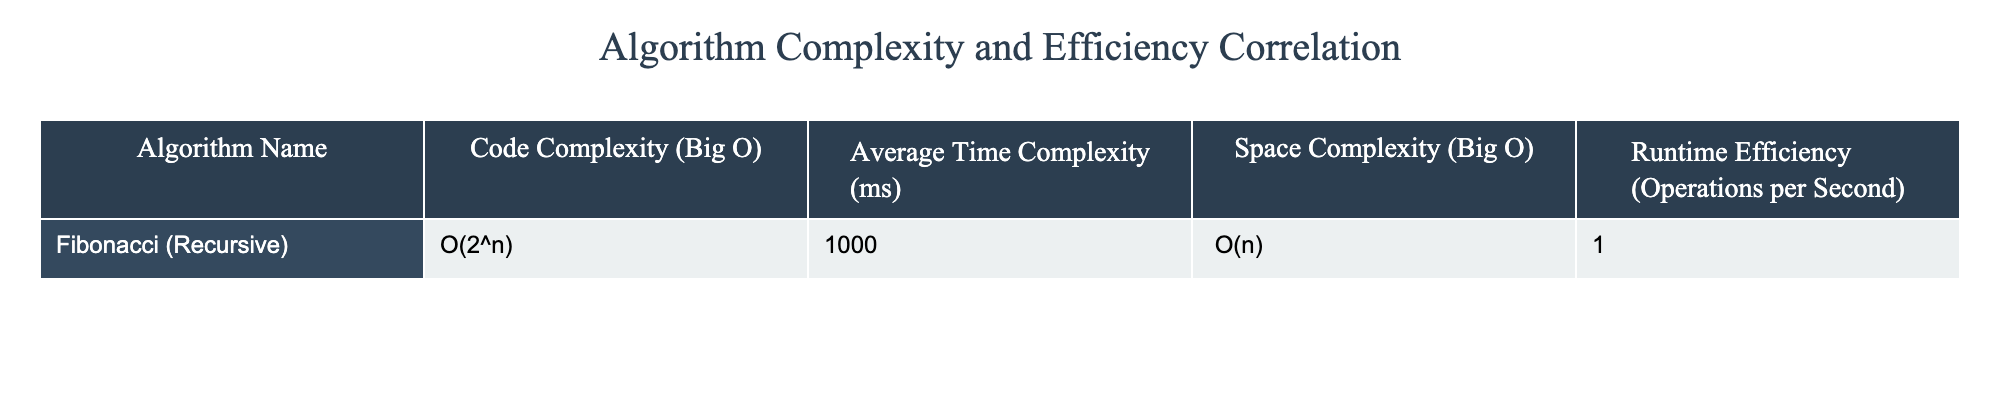What is the code complexity of the Fibonacci algorithm? The table lists the code complexity for the Fibonacci algorithm as O(2^n). This value can be found directly in the "Code Complexity (Big O)" column next to the Fibonacci algorithm name.
Answer: O(2^n) How much average time does the Fibonacci algorithm take to execute? The table provides the average time complexity in milliseconds for the Fibonacci algorithm, which is 1000 ms, easily referenced in the "Average Time Complexity (ms)" column.
Answer: 1000 ms What is the space complexity of the Fibonacci algorithm? Checking the "Space Complexity (Big O)" column for the Fibonacci algorithm shows that its space complexity is O(n). This is a direct retrieval from the provided data.
Answer: O(n) Is the runtime efficiency of the Fibonacci algorithm greater than 1 operation per second? The runtime efficiency for the Fibonacci algorithm is stated as 1 operation per second. Since both values are equal, the statement is false.
Answer: No What is the relationship between code complexity and runtime efficiency for the Fibonacci algorithm? The code complexity of the Fibonacci algorithm is O(2^n), which is quite high, while its runtime efficiency is only 1 operation per second. This suggests that as code complexity increases, runtime efficiency decreases significantly.
Answer: High code complexity correlates with low runtime efficiency What is the difference in average time complexity between the Fibonacci algorithm and an algorithm with a linear average time complexity? We need to calculate the difference. If a linear algorithm takes, for example, 100 ms, then the difference would be 1000 ms (Fibonacci) - 100 ms = 900 ms. Thus, the Fibonacci algorithm is slower by 900 ms when compared to a linear time complexity algorithm.
Answer: 900 ms Which algorithm has the highest code complexity? Since the table only contains data for the Fibonacci algorithm, it stands as the highest with O(2^n). Thus, there are no other algorithms listed to compare against.
Answer: Fibonacci algorithm If we assume that an algorithm with O(n) complexity takes 100 times more operations per second than the Fibonacci algorithm, what would that operations per second value be? The current operations per second for Fibonacci is 1. If another algorithm has O(n) complexity and is 100 times more efficient, its operations per second would be 1 * 100 = 100 operations per second. This follows basic multiplication to arrive at the final figure.
Answer: 100 operations per second 